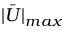Convert formula to latex. <formula><loc_0><loc_0><loc_500><loc_500>\bar { | U | } _ { \max }</formula> 